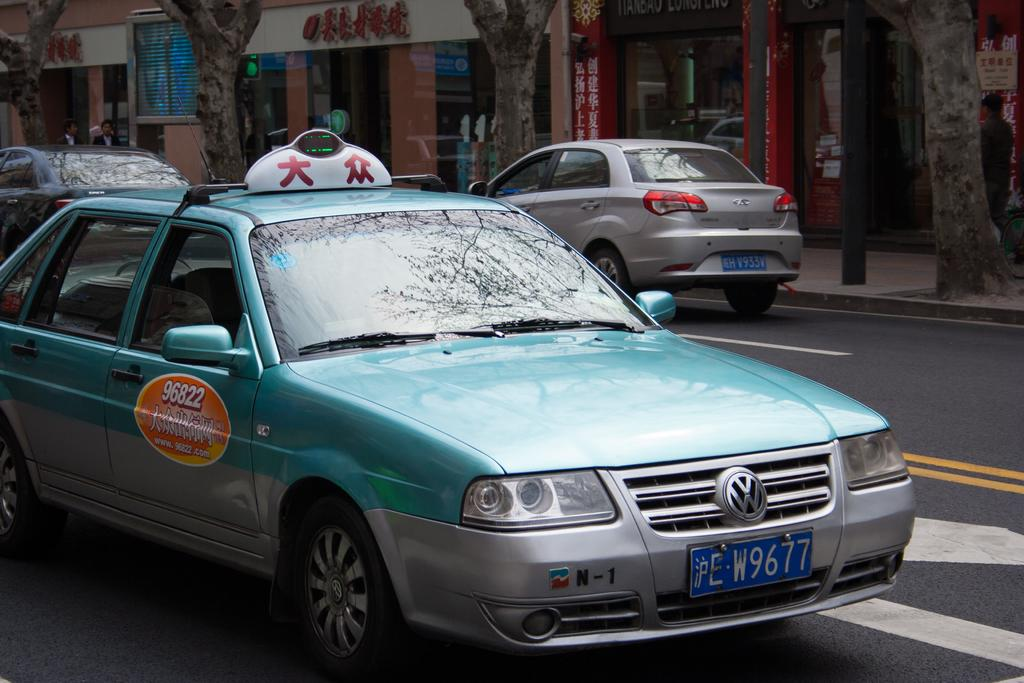<image>
Offer a succinct explanation of the picture presented. The plate number on the car is W9677 